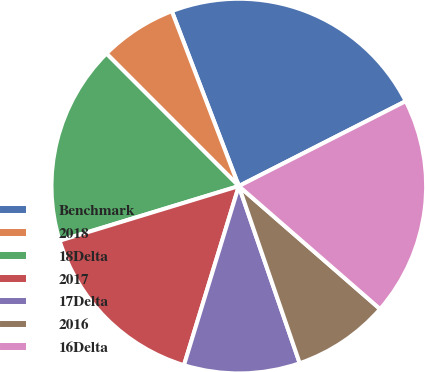Convert chart to OTSL. <chart><loc_0><loc_0><loc_500><loc_500><pie_chart><fcel>Benchmark<fcel>2018<fcel>18Delta<fcel>2017<fcel>17Delta<fcel>2016<fcel>16Delta<nl><fcel>23.33%<fcel>6.67%<fcel>17.22%<fcel>15.56%<fcel>10.0%<fcel>8.33%<fcel>18.89%<nl></chart> 